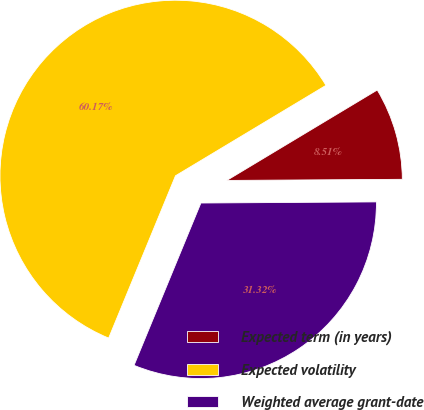<chart> <loc_0><loc_0><loc_500><loc_500><pie_chart><fcel>Expected term (in years)<fcel>Expected volatility<fcel>Weighted average grant-date<nl><fcel>8.51%<fcel>60.17%<fcel>31.32%<nl></chart> 